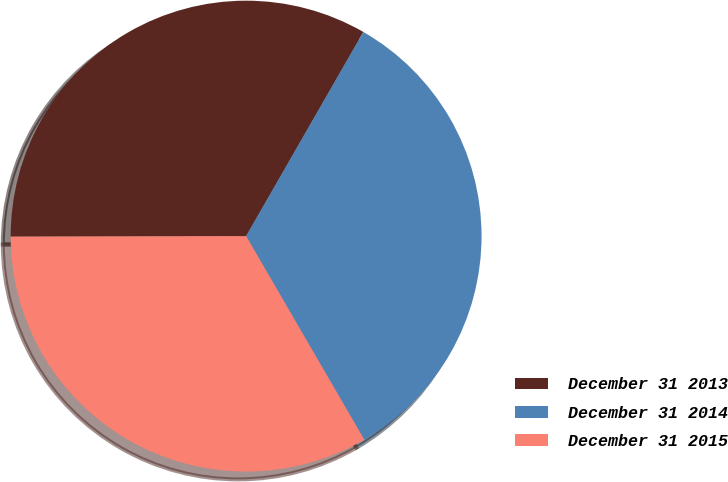Convert chart. <chart><loc_0><loc_0><loc_500><loc_500><pie_chart><fcel>December 31 2013<fcel>December 31 2014<fcel>December 31 2015<nl><fcel>33.33%<fcel>33.33%<fcel>33.33%<nl></chart> 